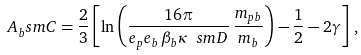Convert formula to latex. <formula><loc_0><loc_0><loc_500><loc_500>A _ { b } ^ { \ } s m C = \frac { 2 } { 3 } \left [ \ln \left ( \frac { 1 6 \pi } { e _ { p } e _ { b } \, \beta _ { b } \kappa _ { \ } s m D } \, \frac { m _ { p b } } { m _ { b } } \right ) - \frac { 1 } { 2 } - 2 \gamma \right ] \, ,</formula> 